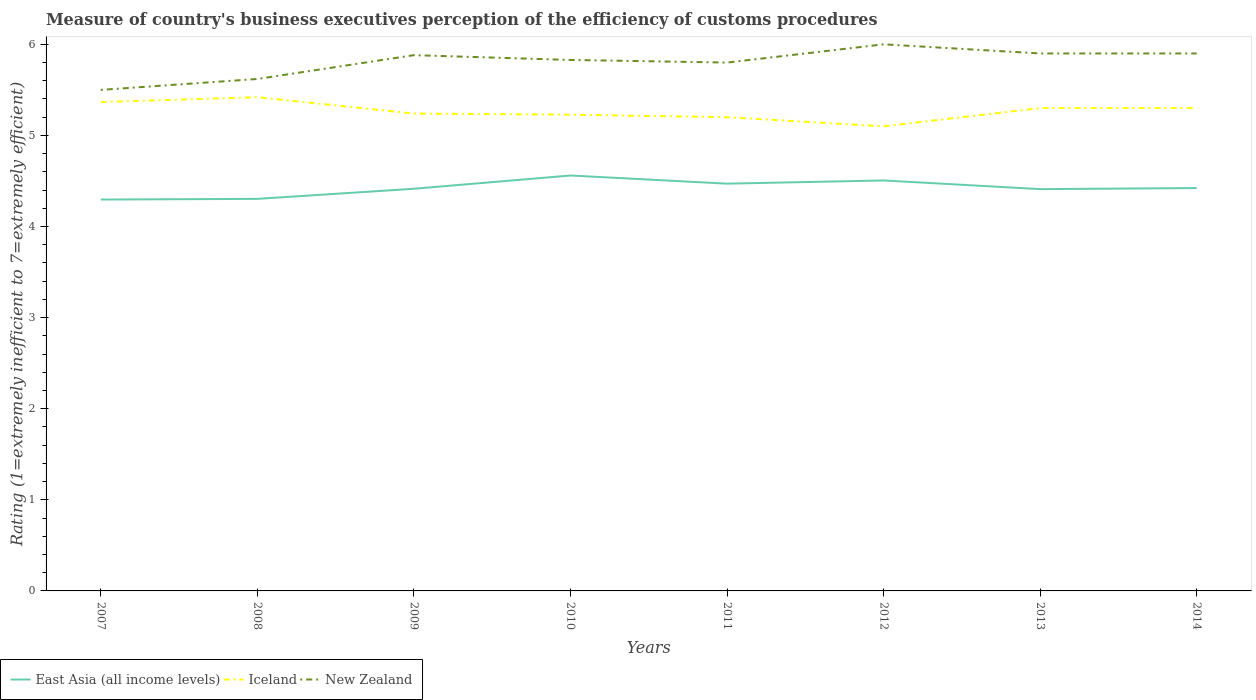How many different coloured lines are there?
Provide a succinct answer. 3. Does the line corresponding to East Asia (all income levels) intersect with the line corresponding to Iceland?
Your answer should be compact. No. Is the number of lines equal to the number of legend labels?
Your answer should be compact. Yes. Across all years, what is the maximum rating of the efficiency of customs procedure in New Zealand?
Offer a very short reply. 5.5. In which year was the rating of the efficiency of customs procedure in East Asia (all income levels) maximum?
Ensure brevity in your answer.  2007. What is the total rating of the efficiency of customs procedure in New Zealand in the graph?
Your answer should be compact. -0.07. What is the difference between the highest and the lowest rating of the efficiency of customs procedure in East Asia (all income levels)?
Give a very brief answer. 3. How many lines are there?
Give a very brief answer. 3. How many years are there in the graph?
Keep it short and to the point. 8. What is the difference between two consecutive major ticks on the Y-axis?
Offer a terse response. 1. Are the values on the major ticks of Y-axis written in scientific E-notation?
Keep it short and to the point. No. Does the graph contain any zero values?
Provide a succinct answer. No. Does the graph contain grids?
Keep it short and to the point. No. How many legend labels are there?
Your response must be concise. 3. What is the title of the graph?
Offer a terse response. Measure of country's business executives perception of the efficiency of customs procedures. What is the label or title of the X-axis?
Offer a terse response. Years. What is the label or title of the Y-axis?
Ensure brevity in your answer.  Rating (1=extremely inefficient to 7=extremely efficient). What is the Rating (1=extremely inefficient to 7=extremely efficient) of East Asia (all income levels) in 2007?
Give a very brief answer. 4.3. What is the Rating (1=extremely inefficient to 7=extremely efficient) of Iceland in 2007?
Ensure brevity in your answer.  5.37. What is the Rating (1=extremely inefficient to 7=extremely efficient) in East Asia (all income levels) in 2008?
Keep it short and to the point. 4.3. What is the Rating (1=extremely inefficient to 7=extremely efficient) in Iceland in 2008?
Your response must be concise. 5.42. What is the Rating (1=extremely inefficient to 7=extremely efficient) in New Zealand in 2008?
Give a very brief answer. 5.62. What is the Rating (1=extremely inefficient to 7=extremely efficient) of East Asia (all income levels) in 2009?
Offer a very short reply. 4.41. What is the Rating (1=extremely inefficient to 7=extremely efficient) in Iceland in 2009?
Offer a very short reply. 5.24. What is the Rating (1=extremely inefficient to 7=extremely efficient) of New Zealand in 2009?
Your response must be concise. 5.88. What is the Rating (1=extremely inefficient to 7=extremely efficient) of East Asia (all income levels) in 2010?
Provide a succinct answer. 4.56. What is the Rating (1=extremely inefficient to 7=extremely efficient) of Iceland in 2010?
Your answer should be compact. 5.23. What is the Rating (1=extremely inefficient to 7=extremely efficient) of New Zealand in 2010?
Offer a terse response. 5.83. What is the Rating (1=extremely inefficient to 7=extremely efficient) in East Asia (all income levels) in 2011?
Give a very brief answer. 4.47. What is the Rating (1=extremely inefficient to 7=extremely efficient) of East Asia (all income levels) in 2012?
Provide a short and direct response. 4.51. What is the Rating (1=extremely inefficient to 7=extremely efficient) of Iceland in 2012?
Your answer should be compact. 5.1. What is the Rating (1=extremely inefficient to 7=extremely efficient) of New Zealand in 2012?
Give a very brief answer. 6. What is the Rating (1=extremely inefficient to 7=extremely efficient) in East Asia (all income levels) in 2013?
Ensure brevity in your answer.  4.41. What is the Rating (1=extremely inefficient to 7=extremely efficient) in New Zealand in 2013?
Provide a short and direct response. 5.9. What is the Rating (1=extremely inefficient to 7=extremely efficient) in East Asia (all income levels) in 2014?
Offer a terse response. 4.42. What is the Rating (1=extremely inefficient to 7=extremely efficient) in New Zealand in 2014?
Provide a short and direct response. 5.9. Across all years, what is the maximum Rating (1=extremely inefficient to 7=extremely efficient) of East Asia (all income levels)?
Offer a very short reply. 4.56. Across all years, what is the maximum Rating (1=extremely inefficient to 7=extremely efficient) of Iceland?
Offer a terse response. 5.42. Across all years, what is the maximum Rating (1=extremely inefficient to 7=extremely efficient) of New Zealand?
Make the answer very short. 6. Across all years, what is the minimum Rating (1=extremely inefficient to 7=extremely efficient) of East Asia (all income levels)?
Keep it short and to the point. 4.3. Across all years, what is the minimum Rating (1=extremely inefficient to 7=extremely efficient) of New Zealand?
Provide a succinct answer. 5.5. What is the total Rating (1=extremely inefficient to 7=extremely efficient) in East Asia (all income levels) in the graph?
Your response must be concise. 35.38. What is the total Rating (1=extremely inefficient to 7=extremely efficient) of Iceland in the graph?
Keep it short and to the point. 42.15. What is the total Rating (1=extremely inefficient to 7=extremely efficient) in New Zealand in the graph?
Give a very brief answer. 46.43. What is the difference between the Rating (1=extremely inefficient to 7=extremely efficient) in East Asia (all income levels) in 2007 and that in 2008?
Ensure brevity in your answer.  -0.01. What is the difference between the Rating (1=extremely inefficient to 7=extremely efficient) in Iceland in 2007 and that in 2008?
Make the answer very short. -0.05. What is the difference between the Rating (1=extremely inefficient to 7=extremely efficient) of New Zealand in 2007 and that in 2008?
Keep it short and to the point. -0.12. What is the difference between the Rating (1=extremely inefficient to 7=extremely efficient) of East Asia (all income levels) in 2007 and that in 2009?
Your response must be concise. -0.12. What is the difference between the Rating (1=extremely inefficient to 7=extremely efficient) in Iceland in 2007 and that in 2009?
Provide a succinct answer. 0.13. What is the difference between the Rating (1=extremely inefficient to 7=extremely efficient) of New Zealand in 2007 and that in 2009?
Your answer should be very brief. -0.38. What is the difference between the Rating (1=extremely inefficient to 7=extremely efficient) of East Asia (all income levels) in 2007 and that in 2010?
Provide a succinct answer. -0.26. What is the difference between the Rating (1=extremely inefficient to 7=extremely efficient) in Iceland in 2007 and that in 2010?
Your answer should be very brief. 0.14. What is the difference between the Rating (1=extremely inefficient to 7=extremely efficient) in New Zealand in 2007 and that in 2010?
Make the answer very short. -0.33. What is the difference between the Rating (1=extremely inefficient to 7=extremely efficient) in East Asia (all income levels) in 2007 and that in 2011?
Give a very brief answer. -0.17. What is the difference between the Rating (1=extremely inefficient to 7=extremely efficient) in Iceland in 2007 and that in 2011?
Ensure brevity in your answer.  0.17. What is the difference between the Rating (1=extremely inefficient to 7=extremely efficient) in New Zealand in 2007 and that in 2011?
Keep it short and to the point. -0.3. What is the difference between the Rating (1=extremely inefficient to 7=extremely efficient) in East Asia (all income levels) in 2007 and that in 2012?
Provide a succinct answer. -0.21. What is the difference between the Rating (1=extremely inefficient to 7=extremely efficient) of Iceland in 2007 and that in 2012?
Your answer should be compact. 0.27. What is the difference between the Rating (1=extremely inefficient to 7=extremely efficient) in New Zealand in 2007 and that in 2012?
Keep it short and to the point. -0.5. What is the difference between the Rating (1=extremely inefficient to 7=extremely efficient) in East Asia (all income levels) in 2007 and that in 2013?
Your answer should be compact. -0.11. What is the difference between the Rating (1=extremely inefficient to 7=extremely efficient) of Iceland in 2007 and that in 2013?
Your answer should be very brief. 0.07. What is the difference between the Rating (1=extremely inefficient to 7=extremely efficient) in East Asia (all income levels) in 2007 and that in 2014?
Provide a succinct answer. -0.13. What is the difference between the Rating (1=extremely inefficient to 7=extremely efficient) in Iceland in 2007 and that in 2014?
Make the answer very short. 0.07. What is the difference between the Rating (1=extremely inefficient to 7=extremely efficient) of New Zealand in 2007 and that in 2014?
Provide a succinct answer. -0.4. What is the difference between the Rating (1=extremely inefficient to 7=extremely efficient) of East Asia (all income levels) in 2008 and that in 2009?
Give a very brief answer. -0.11. What is the difference between the Rating (1=extremely inefficient to 7=extremely efficient) in Iceland in 2008 and that in 2009?
Your response must be concise. 0.18. What is the difference between the Rating (1=extremely inefficient to 7=extremely efficient) of New Zealand in 2008 and that in 2009?
Give a very brief answer. -0.26. What is the difference between the Rating (1=extremely inefficient to 7=extremely efficient) in East Asia (all income levels) in 2008 and that in 2010?
Your answer should be compact. -0.26. What is the difference between the Rating (1=extremely inefficient to 7=extremely efficient) in Iceland in 2008 and that in 2010?
Keep it short and to the point. 0.19. What is the difference between the Rating (1=extremely inefficient to 7=extremely efficient) of New Zealand in 2008 and that in 2010?
Ensure brevity in your answer.  -0.21. What is the difference between the Rating (1=extremely inefficient to 7=extremely efficient) of East Asia (all income levels) in 2008 and that in 2011?
Provide a short and direct response. -0.17. What is the difference between the Rating (1=extremely inefficient to 7=extremely efficient) in Iceland in 2008 and that in 2011?
Your answer should be very brief. 0.22. What is the difference between the Rating (1=extremely inefficient to 7=extremely efficient) of New Zealand in 2008 and that in 2011?
Offer a terse response. -0.18. What is the difference between the Rating (1=extremely inefficient to 7=extremely efficient) of East Asia (all income levels) in 2008 and that in 2012?
Keep it short and to the point. -0.2. What is the difference between the Rating (1=extremely inefficient to 7=extremely efficient) in Iceland in 2008 and that in 2012?
Your answer should be compact. 0.32. What is the difference between the Rating (1=extremely inefficient to 7=extremely efficient) of New Zealand in 2008 and that in 2012?
Offer a very short reply. -0.38. What is the difference between the Rating (1=extremely inefficient to 7=extremely efficient) in East Asia (all income levels) in 2008 and that in 2013?
Offer a terse response. -0.11. What is the difference between the Rating (1=extremely inefficient to 7=extremely efficient) of Iceland in 2008 and that in 2013?
Make the answer very short. 0.12. What is the difference between the Rating (1=extremely inefficient to 7=extremely efficient) in New Zealand in 2008 and that in 2013?
Keep it short and to the point. -0.28. What is the difference between the Rating (1=extremely inefficient to 7=extremely efficient) in East Asia (all income levels) in 2008 and that in 2014?
Offer a terse response. -0.12. What is the difference between the Rating (1=extremely inefficient to 7=extremely efficient) in Iceland in 2008 and that in 2014?
Ensure brevity in your answer.  0.12. What is the difference between the Rating (1=extremely inefficient to 7=extremely efficient) of New Zealand in 2008 and that in 2014?
Offer a terse response. -0.28. What is the difference between the Rating (1=extremely inefficient to 7=extremely efficient) in East Asia (all income levels) in 2009 and that in 2010?
Your answer should be compact. -0.15. What is the difference between the Rating (1=extremely inefficient to 7=extremely efficient) of Iceland in 2009 and that in 2010?
Offer a very short reply. 0.01. What is the difference between the Rating (1=extremely inefficient to 7=extremely efficient) of New Zealand in 2009 and that in 2010?
Make the answer very short. 0.05. What is the difference between the Rating (1=extremely inefficient to 7=extremely efficient) in East Asia (all income levels) in 2009 and that in 2011?
Offer a very short reply. -0.06. What is the difference between the Rating (1=extremely inefficient to 7=extremely efficient) of Iceland in 2009 and that in 2011?
Offer a terse response. 0.04. What is the difference between the Rating (1=extremely inefficient to 7=extremely efficient) in New Zealand in 2009 and that in 2011?
Give a very brief answer. 0.08. What is the difference between the Rating (1=extremely inefficient to 7=extremely efficient) in East Asia (all income levels) in 2009 and that in 2012?
Make the answer very short. -0.09. What is the difference between the Rating (1=extremely inefficient to 7=extremely efficient) in Iceland in 2009 and that in 2012?
Your answer should be very brief. 0.14. What is the difference between the Rating (1=extremely inefficient to 7=extremely efficient) in New Zealand in 2009 and that in 2012?
Your response must be concise. -0.12. What is the difference between the Rating (1=extremely inefficient to 7=extremely efficient) in East Asia (all income levels) in 2009 and that in 2013?
Ensure brevity in your answer.  0. What is the difference between the Rating (1=extremely inefficient to 7=extremely efficient) of Iceland in 2009 and that in 2013?
Make the answer very short. -0.06. What is the difference between the Rating (1=extremely inefficient to 7=extremely efficient) in New Zealand in 2009 and that in 2013?
Offer a very short reply. -0.02. What is the difference between the Rating (1=extremely inefficient to 7=extremely efficient) in East Asia (all income levels) in 2009 and that in 2014?
Offer a terse response. -0.01. What is the difference between the Rating (1=extremely inefficient to 7=extremely efficient) of Iceland in 2009 and that in 2014?
Provide a short and direct response. -0.06. What is the difference between the Rating (1=extremely inefficient to 7=extremely efficient) in New Zealand in 2009 and that in 2014?
Make the answer very short. -0.02. What is the difference between the Rating (1=extremely inefficient to 7=extremely efficient) in East Asia (all income levels) in 2010 and that in 2011?
Your response must be concise. 0.09. What is the difference between the Rating (1=extremely inefficient to 7=extremely efficient) in Iceland in 2010 and that in 2011?
Keep it short and to the point. 0.03. What is the difference between the Rating (1=extremely inefficient to 7=extremely efficient) in New Zealand in 2010 and that in 2011?
Make the answer very short. 0.03. What is the difference between the Rating (1=extremely inefficient to 7=extremely efficient) of East Asia (all income levels) in 2010 and that in 2012?
Ensure brevity in your answer.  0.05. What is the difference between the Rating (1=extremely inefficient to 7=extremely efficient) in Iceland in 2010 and that in 2012?
Provide a short and direct response. 0.13. What is the difference between the Rating (1=extremely inefficient to 7=extremely efficient) in New Zealand in 2010 and that in 2012?
Provide a short and direct response. -0.17. What is the difference between the Rating (1=extremely inefficient to 7=extremely efficient) of East Asia (all income levels) in 2010 and that in 2013?
Your response must be concise. 0.15. What is the difference between the Rating (1=extremely inefficient to 7=extremely efficient) in Iceland in 2010 and that in 2013?
Your answer should be very brief. -0.07. What is the difference between the Rating (1=extremely inefficient to 7=extremely efficient) in New Zealand in 2010 and that in 2013?
Your answer should be compact. -0.07. What is the difference between the Rating (1=extremely inefficient to 7=extremely efficient) in East Asia (all income levels) in 2010 and that in 2014?
Your answer should be compact. 0.14. What is the difference between the Rating (1=extremely inefficient to 7=extremely efficient) in Iceland in 2010 and that in 2014?
Offer a very short reply. -0.07. What is the difference between the Rating (1=extremely inefficient to 7=extremely efficient) of New Zealand in 2010 and that in 2014?
Keep it short and to the point. -0.07. What is the difference between the Rating (1=extremely inefficient to 7=extremely efficient) of East Asia (all income levels) in 2011 and that in 2012?
Make the answer very short. -0.04. What is the difference between the Rating (1=extremely inefficient to 7=extremely efficient) of Iceland in 2011 and that in 2012?
Offer a very short reply. 0.1. What is the difference between the Rating (1=extremely inefficient to 7=extremely efficient) of New Zealand in 2011 and that in 2012?
Your answer should be very brief. -0.2. What is the difference between the Rating (1=extremely inefficient to 7=extremely efficient) of East Asia (all income levels) in 2011 and that in 2013?
Provide a succinct answer. 0.06. What is the difference between the Rating (1=extremely inefficient to 7=extremely efficient) in New Zealand in 2011 and that in 2013?
Your answer should be very brief. -0.1. What is the difference between the Rating (1=extremely inefficient to 7=extremely efficient) in East Asia (all income levels) in 2011 and that in 2014?
Ensure brevity in your answer.  0.05. What is the difference between the Rating (1=extremely inefficient to 7=extremely efficient) in Iceland in 2011 and that in 2014?
Provide a short and direct response. -0.1. What is the difference between the Rating (1=extremely inefficient to 7=extremely efficient) of New Zealand in 2011 and that in 2014?
Your answer should be very brief. -0.1. What is the difference between the Rating (1=extremely inefficient to 7=extremely efficient) of East Asia (all income levels) in 2012 and that in 2013?
Your response must be concise. 0.1. What is the difference between the Rating (1=extremely inefficient to 7=extremely efficient) in East Asia (all income levels) in 2012 and that in 2014?
Your response must be concise. 0.08. What is the difference between the Rating (1=extremely inefficient to 7=extremely efficient) of East Asia (all income levels) in 2013 and that in 2014?
Make the answer very short. -0.01. What is the difference between the Rating (1=extremely inefficient to 7=extremely efficient) in East Asia (all income levels) in 2007 and the Rating (1=extremely inefficient to 7=extremely efficient) in Iceland in 2008?
Ensure brevity in your answer.  -1.12. What is the difference between the Rating (1=extremely inefficient to 7=extremely efficient) of East Asia (all income levels) in 2007 and the Rating (1=extremely inefficient to 7=extremely efficient) of New Zealand in 2008?
Offer a terse response. -1.32. What is the difference between the Rating (1=extremely inefficient to 7=extremely efficient) in Iceland in 2007 and the Rating (1=extremely inefficient to 7=extremely efficient) in New Zealand in 2008?
Provide a succinct answer. -0.25. What is the difference between the Rating (1=extremely inefficient to 7=extremely efficient) of East Asia (all income levels) in 2007 and the Rating (1=extremely inefficient to 7=extremely efficient) of Iceland in 2009?
Offer a very short reply. -0.94. What is the difference between the Rating (1=extremely inefficient to 7=extremely efficient) of East Asia (all income levels) in 2007 and the Rating (1=extremely inefficient to 7=extremely efficient) of New Zealand in 2009?
Offer a very short reply. -1.58. What is the difference between the Rating (1=extremely inefficient to 7=extremely efficient) in Iceland in 2007 and the Rating (1=extremely inefficient to 7=extremely efficient) in New Zealand in 2009?
Provide a short and direct response. -0.51. What is the difference between the Rating (1=extremely inefficient to 7=extremely efficient) in East Asia (all income levels) in 2007 and the Rating (1=extremely inefficient to 7=extremely efficient) in Iceland in 2010?
Offer a very short reply. -0.93. What is the difference between the Rating (1=extremely inefficient to 7=extremely efficient) in East Asia (all income levels) in 2007 and the Rating (1=extremely inefficient to 7=extremely efficient) in New Zealand in 2010?
Your response must be concise. -1.53. What is the difference between the Rating (1=extremely inefficient to 7=extremely efficient) in Iceland in 2007 and the Rating (1=extremely inefficient to 7=extremely efficient) in New Zealand in 2010?
Your response must be concise. -0.46. What is the difference between the Rating (1=extremely inefficient to 7=extremely efficient) in East Asia (all income levels) in 2007 and the Rating (1=extremely inefficient to 7=extremely efficient) in Iceland in 2011?
Make the answer very short. -0.9. What is the difference between the Rating (1=extremely inefficient to 7=extremely efficient) in East Asia (all income levels) in 2007 and the Rating (1=extremely inefficient to 7=extremely efficient) in New Zealand in 2011?
Give a very brief answer. -1.5. What is the difference between the Rating (1=extremely inefficient to 7=extremely efficient) in Iceland in 2007 and the Rating (1=extremely inefficient to 7=extremely efficient) in New Zealand in 2011?
Provide a succinct answer. -0.43. What is the difference between the Rating (1=extremely inefficient to 7=extremely efficient) of East Asia (all income levels) in 2007 and the Rating (1=extremely inefficient to 7=extremely efficient) of Iceland in 2012?
Make the answer very short. -0.8. What is the difference between the Rating (1=extremely inefficient to 7=extremely efficient) of East Asia (all income levels) in 2007 and the Rating (1=extremely inefficient to 7=extremely efficient) of New Zealand in 2012?
Give a very brief answer. -1.7. What is the difference between the Rating (1=extremely inefficient to 7=extremely efficient) of Iceland in 2007 and the Rating (1=extremely inefficient to 7=extremely efficient) of New Zealand in 2012?
Offer a very short reply. -0.63. What is the difference between the Rating (1=extremely inefficient to 7=extremely efficient) in East Asia (all income levels) in 2007 and the Rating (1=extremely inefficient to 7=extremely efficient) in Iceland in 2013?
Your answer should be compact. -1. What is the difference between the Rating (1=extremely inefficient to 7=extremely efficient) of East Asia (all income levels) in 2007 and the Rating (1=extremely inefficient to 7=extremely efficient) of New Zealand in 2013?
Your response must be concise. -1.6. What is the difference between the Rating (1=extremely inefficient to 7=extremely efficient) of Iceland in 2007 and the Rating (1=extremely inefficient to 7=extremely efficient) of New Zealand in 2013?
Keep it short and to the point. -0.53. What is the difference between the Rating (1=extremely inefficient to 7=extremely efficient) in East Asia (all income levels) in 2007 and the Rating (1=extremely inefficient to 7=extremely efficient) in Iceland in 2014?
Ensure brevity in your answer.  -1. What is the difference between the Rating (1=extremely inefficient to 7=extremely efficient) of East Asia (all income levels) in 2007 and the Rating (1=extremely inefficient to 7=extremely efficient) of New Zealand in 2014?
Ensure brevity in your answer.  -1.6. What is the difference between the Rating (1=extremely inefficient to 7=extremely efficient) in Iceland in 2007 and the Rating (1=extremely inefficient to 7=extremely efficient) in New Zealand in 2014?
Offer a terse response. -0.53. What is the difference between the Rating (1=extremely inefficient to 7=extremely efficient) in East Asia (all income levels) in 2008 and the Rating (1=extremely inefficient to 7=extremely efficient) in Iceland in 2009?
Keep it short and to the point. -0.94. What is the difference between the Rating (1=extremely inefficient to 7=extremely efficient) of East Asia (all income levels) in 2008 and the Rating (1=extremely inefficient to 7=extremely efficient) of New Zealand in 2009?
Your answer should be compact. -1.58. What is the difference between the Rating (1=extremely inefficient to 7=extremely efficient) in Iceland in 2008 and the Rating (1=extremely inefficient to 7=extremely efficient) in New Zealand in 2009?
Keep it short and to the point. -0.46. What is the difference between the Rating (1=extremely inefficient to 7=extremely efficient) in East Asia (all income levels) in 2008 and the Rating (1=extremely inefficient to 7=extremely efficient) in Iceland in 2010?
Provide a short and direct response. -0.92. What is the difference between the Rating (1=extremely inefficient to 7=extremely efficient) in East Asia (all income levels) in 2008 and the Rating (1=extremely inefficient to 7=extremely efficient) in New Zealand in 2010?
Your answer should be compact. -1.52. What is the difference between the Rating (1=extremely inefficient to 7=extremely efficient) of Iceland in 2008 and the Rating (1=extremely inefficient to 7=extremely efficient) of New Zealand in 2010?
Offer a very short reply. -0.41. What is the difference between the Rating (1=extremely inefficient to 7=extremely efficient) of East Asia (all income levels) in 2008 and the Rating (1=extremely inefficient to 7=extremely efficient) of Iceland in 2011?
Provide a short and direct response. -0.9. What is the difference between the Rating (1=extremely inefficient to 7=extremely efficient) of East Asia (all income levels) in 2008 and the Rating (1=extremely inefficient to 7=extremely efficient) of New Zealand in 2011?
Provide a succinct answer. -1.5. What is the difference between the Rating (1=extremely inefficient to 7=extremely efficient) of Iceland in 2008 and the Rating (1=extremely inefficient to 7=extremely efficient) of New Zealand in 2011?
Your response must be concise. -0.38. What is the difference between the Rating (1=extremely inefficient to 7=extremely efficient) in East Asia (all income levels) in 2008 and the Rating (1=extremely inefficient to 7=extremely efficient) in Iceland in 2012?
Make the answer very short. -0.8. What is the difference between the Rating (1=extremely inefficient to 7=extremely efficient) of East Asia (all income levels) in 2008 and the Rating (1=extremely inefficient to 7=extremely efficient) of New Zealand in 2012?
Provide a succinct answer. -1.7. What is the difference between the Rating (1=extremely inefficient to 7=extremely efficient) in Iceland in 2008 and the Rating (1=extremely inefficient to 7=extremely efficient) in New Zealand in 2012?
Provide a succinct answer. -0.58. What is the difference between the Rating (1=extremely inefficient to 7=extremely efficient) in East Asia (all income levels) in 2008 and the Rating (1=extremely inefficient to 7=extremely efficient) in Iceland in 2013?
Your answer should be compact. -1. What is the difference between the Rating (1=extremely inefficient to 7=extremely efficient) of East Asia (all income levels) in 2008 and the Rating (1=extremely inefficient to 7=extremely efficient) of New Zealand in 2013?
Ensure brevity in your answer.  -1.6. What is the difference between the Rating (1=extremely inefficient to 7=extremely efficient) in Iceland in 2008 and the Rating (1=extremely inefficient to 7=extremely efficient) in New Zealand in 2013?
Your answer should be compact. -0.48. What is the difference between the Rating (1=extremely inefficient to 7=extremely efficient) of East Asia (all income levels) in 2008 and the Rating (1=extremely inefficient to 7=extremely efficient) of Iceland in 2014?
Provide a short and direct response. -1. What is the difference between the Rating (1=extremely inefficient to 7=extremely efficient) in East Asia (all income levels) in 2008 and the Rating (1=extremely inefficient to 7=extremely efficient) in New Zealand in 2014?
Your response must be concise. -1.6. What is the difference between the Rating (1=extremely inefficient to 7=extremely efficient) of Iceland in 2008 and the Rating (1=extremely inefficient to 7=extremely efficient) of New Zealand in 2014?
Provide a succinct answer. -0.48. What is the difference between the Rating (1=extremely inefficient to 7=extremely efficient) in East Asia (all income levels) in 2009 and the Rating (1=extremely inefficient to 7=extremely efficient) in Iceland in 2010?
Make the answer very short. -0.81. What is the difference between the Rating (1=extremely inefficient to 7=extremely efficient) of East Asia (all income levels) in 2009 and the Rating (1=extremely inefficient to 7=extremely efficient) of New Zealand in 2010?
Offer a very short reply. -1.41. What is the difference between the Rating (1=extremely inefficient to 7=extremely efficient) of Iceland in 2009 and the Rating (1=extremely inefficient to 7=extremely efficient) of New Zealand in 2010?
Provide a short and direct response. -0.59. What is the difference between the Rating (1=extremely inefficient to 7=extremely efficient) of East Asia (all income levels) in 2009 and the Rating (1=extremely inefficient to 7=extremely efficient) of Iceland in 2011?
Make the answer very short. -0.79. What is the difference between the Rating (1=extremely inefficient to 7=extremely efficient) in East Asia (all income levels) in 2009 and the Rating (1=extremely inefficient to 7=extremely efficient) in New Zealand in 2011?
Offer a terse response. -1.39. What is the difference between the Rating (1=extremely inefficient to 7=extremely efficient) of Iceland in 2009 and the Rating (1=extremely inefficient to 7=extremely efficient) of New Zealand in 2011?
Keep it short and to the point. -0.56. What is the difference between the Rating (1=extremely inefficient to 7=extremely efficient) in East Asia (all income levels) in 2009 and the Rating (1=extremely inefficient to 7=extremely efficient) in Iceland in 2012?
Your response must be concise. -0.69. What is the difference between the Rating (1=extremely inefficient to 7=extremely efficient) of East Asia (all income levels) in 2009 and the Rating (1=extremely inefficient to 7=extremely efficient) of New Zealand in 2012?
Your response must be concise. -1.59. What is the difference between the Rating (1=extremely inefficient to 7=extremely efficient) in Iceland in 2009 and the Rating (1=extremely inefficient to 7=extremely efficient) in New Zealand in 2012?
Make the answer very short. -0.76. What is the difference between the Rating (1=extremely inefficient to 7=extremely efficient) in East Asia (all income levels) in 2009 and the Rating (1=extremely inefficient to 7=extremely efficient) in Iceland in 2013?
Ensure brevity in your answer.  -0.89. What is the difference between the Rating (1=extremely inefficient to 7=extremely efficient) in East Asia (all income levels) in 2009 and the Rating (1=extremely inefficient to 7=extremely efficient) in New Zealand in 2013?
Make the answer very short. -1.49. What is the difference between the Rating (1=extremely inefficient to 7=extremely efficient) in Iceland in 2009 and the Rating (1=extremely inefficient to 7=extremely efficient) in New Zealand in 2013?
Provide a short and direct response. -0.66. What is the difference between the Rating (1=extremely inefficient to 7=extremely efficient) in East Asia (all income levels) in 2009 and the Rating (1=extremely inefficient to 7=extremely efficient) in Iceland in 2014?
Provide a short and direct response. -0.89. What is the difference between the Rating (1=extremely inefficient to 7=extremely efficient) in East Asia (all income levels) in 2009 and the Rating (1=extremely inefficient to 7=extremely efficient) in New Zealand in 2014?
Offer a very short reply. -1.49. What is the difference between the Rating (1=extremely inefficient to 7=extremely efficient) of Iceland in 2009 and the Rating (1=extremely inefficient to 7=extremely efficient) of New Zealand in 2014?
Provide a short and direct response. -0.66. What is the difference between the Rating (1=extremely inefficient to 7=extremely efficient) in East Asia (all income levels) in 2010 and the Rating (1=extremely inefficient to 7=extremely efficient) in Iceland in 2011?
Your response must be concise. -0.64. What is the difference between the Rating (1=extremely inefficient to 7=extremely efficient) in East Asia (all income levels) in 2010 and the Rating (1=extremely inefficient to 7=extremely efficient) in New Zealand in 2011?
Provide a short and direct response. -1.24. What is the difference between the Rating (1=extremely inefficient to 7=extremely efficient) in Iceland in 2010 and the Rating (1=extremely inefficient to 7=extremely efficient) in New Zealand in 2011?
Your answer should be very brief. -0.57. What is the difference between the Rating (1=extremely inefficient to 7=extremely efficient) in East Asia (all income levels) in 2010 and the Rating (1=extremely inefficient to 7=extremely efficient) in Iceland in 2012?
Provide a succinct answer. -0.54. What is the difference between the Rating (1=extremely inefficient to 7=extremely efficient) of East Asia (all income levels) in 2010 and the Rating (1=extremely inefficient to 7=extremely efficient) of New Zealand in 2012?
Provide a short and direct response. -1.44. What is the difference between the Rating (1=extremely inefficient to 7=extremely efficient) in Iceland in 2010 and the Rating (1=extremely inefficient to 7=extremely efficient) in New Zealand in 2012?
Your answer should be very brief. -0.77. What is the difference between the Rating (1=extremely inefficient to 7=extremely efficient) of East Asia (all income levels) in 2010 and the Rating (1=extremely inefficient to 7=extremely efficient) of Iceland in 2013?
Offer a terse response. -0.74. What is the difference between the Rating (1=extremely inefficient to 7=extremely efficient) of East Asia (all income levels) in 2010 and the Rating (1=extremely inefficient to 7=extremely efficient) of New Zealand in 2013?
Your answer should be very brief. -1.34. What is the difference between the Rating (1=extremely inefficient to 7=extremely efficient) of Iceland in 2010 and the Rating (1=extremely inefficient to 7=extremely efficient) of New Zealand in 2013?
Your answer should be compact. -0.67. What is the difference between the Rating (1=extremely inefficient to 7=extremely efficient) of East Asia (all income levels) in 2010 and the Rating (1=extremely inefficient to 7=extremely efficient) of Iceland in 2014?
Ensure brevity in your answer.  -0.74. What is the difference between the Rating (1=extremely inefficient to 7=extremely efficient) of East Asia (all income levels) in 2010 and the Rating (1=extremely inefficient to 7=extremely efficient) of New Zealand in 2014?
Keep it short and to the point. -1.34. What is the difference between the Rating (1=extremely inefficient to 7=extremely efficient) of Iceland in 2010 and the Rating (1=extremely inefficient to 7=extremely efficient) of New Zealand in 2014?
Make the answer very short. -0.67. What is the difference between the Rating (1=extremely inefficient to 7=extremely efficient) of East Asia (all income levels) in 2011 and the Rating (1=extremely inefficient to 7=extremely efficient) of Iceland in 2012?
Offer a terse response. -0.63. What is the difference between the Rating (1=extremely inefficient to 7=extremely efficient) in East Asia (all income levels) in 2011 and the Rating (1=extremely inefficient to 7=extremely efficient) in New Zealand in 2012?
Your response must be concise. -1.53. What is the difference between the Rating (1=extremely inefficient to 7=extremely efficient) of Iceland in 2011 and the Rating (1=extremely inefficient to 7=extremely efficient) of New Zealand in 2012?
Keep it short and to the point. -0.8. What is the difference between the Rating (1=extremely inefficient to 7=extremely efficient) in East Asia (all income levels) in 2011 and the Rating (1=extremely inefficient to 7=extremely efficient) in Iceland in 2013?
Make the answer very short. -0.83. What is the difference between the Rating (1=extremely inefficient to 7=extremely efficient) of East Asia (all income levels) in 2011 and the Rating (1=extremely inefficient to 7=extremely efficient) of New Zealand in 2013?
Offer a terse response. -1.43. What is the difference between the Rating (1=extremely inefficient to 7=extremely efficient) of Iceland in 2011 and the Rating (1=extremely inefficient to 7=extremely efficient) of New Zealand in 2013?
Offer a very short reply. -0.7. What is the difference between the Rating (1=extremely inefficient to 7=extremely efficient) of East Asia (all income levels) in 2011 and the Rating (1=extremely inefficient to 7=extremely efficient) of Iceland in 2014?
Keep it short and to the point. -0.83. What is the difference between the Rating (1=extremely inefficient to 7=extremely efficient) of East Asia (all income levels) in 2011 and the Rating (1=extremely inefficient to 7=extremely efficient) of New Zealand in 2014?
Offer a very short reply. -1.43. What is the difference between the Rating (1=extremely inefficient to 7=extremely efficient) of East Asia (all income levels) in 2012 and the Rating (1=extremely inefficient to 7=extremely efficient) of Iceland in 2013?
Offer a very short reply. -0.79. What is the difference between the Rating (1=extremely inefficient to 7=extremely efficient) in East Asia (all income levels) in 2012 and the Rating (1=extremely inefficient to 7=extremely efficient) in New Zealand in 2013?
Offer a very short reply. -1.39. What is the difference between the Rating (1=extremely inefficient to 7=extremely efficient) of Iceland in 2012 and the Rating (1=extremely inefficient to 7=extremely efficient) of New Zealand in 2013?
Provide a short and direct response. -0.8. What is the difference between the Rating (1=extremely inefficient to 7=extremely efficient) of East Asia (all income levels) in 2012 and the Rating (1=extremely inefficient to 7=extremely efficient) of Iceland in 2014?
Provide a short and direct response. -0.79. What is the difference between the Rating (1=extremely inefficient to 7=extremely efficient) in East Asia (all income levels) in 2012 and the Rating (1=extremely inefficient to 7=extremely efficient) in New Zealand in 2014?
Provide a succinct answer. -1.39. What is the difference between the Rating (1=extremely inefficient to 7=extremely efficient) of East Asia (all income levels) in 2013 and the Rating (1=extremely inefficient to 7=extremely efficient) of Iceland in 2014?
Keep it short and to the point. -0.89. What is the difference between the Rating (1=extremely inefficient to 7=extremely efficient) in East Asia (all income levels) in 2013 and the Rating (1=extremely inefficient to 7=extremely efficient) in New Zealand in 2014?
Make the answer very short. -1.49. What is the difference between the Rating (1=extremely inefficient to 7=extremely efficient) in Iceland in 2013 and the Rating (1=extremely inefficient to 7=extremely efficient) in New Zealand in 2014?
Your answer should be compact. -0.6. What is the average Rating (1=extremely inefficient to 7=extremely efficient) of East Asia (all income levels) per year?
Offer a terse response. 4.42. What is the average Rating (1=extremely inefficient to 7=extremely efficient) of Iceland per year?
Offer a very short reply. 5.27. What is the average Rating (1=extremely inefficient to 7=extremely efficient) of New Zealand per year?
Make the answer very short. 5.8. In the year 2007, what is the difference between the Rating (1=extremely inefficient to 7=extremely efficient) of East Asia (all income levels) and Rating (1=extremely inefficient to 7=extremely efficient) of Iceland?
Your answer should be compact. -1.07. In the year 2007, what is the difference between the Rating (1=extremely inefficient to 7=extremely efficient) of East Asia (all income levels) and Rating (1=extremely inefficient to 7=extremely efficient) of New Zealand?
Provide a short and direct response. -1.2. In the year 2007, what is the difference between the Rating (1=extremely inefficient to 7=extremely efficient) in Iceland and Rating (1=extremely inefficient to 7=extremely efficient) in New Zealand?
Provide a succinct answer. -0.13. In the year 2008, what is the difference between the Rating (1=extremely inefficient to 7=extremely efficient) of East Asia (all income levels) and Rating (1=extremely inefficient to 7=extremely efficient) of Iceland?
Ensure brevity in your answer.  -1.12. In the year 2008, what is the difference between the Rating (1=extremely inefficient to 7=extremely efficient) of East Asia (all income levels) and Rating (1=extremely inefficient to 7=extremely efficient) of New Zealand?
Make the answer very short. -1.32. In the year 2008, what is the difference between the Rating (1=extremely inefficient to 7=extremely efficient) of Iceland and Rating (1=extremely inefficient to 7=extremely efficient) of New Zealand?
Your answer should be very brief. -0.2. In the year 2009, what is the difference between the Rating (1=extremely inefficient to 7=extremely efficient) of East Asia (all income levels) and Rating (1=extremely inefficient to 7=extremely efficient) of Iceland?
Your answer should be very brief. -0.83. In the year 2009, what is the difference between the Rating (1=extremely inefficient to 7=extremely efficient) of East Asia (all income levels) and Rating (1=extremely inefficient to 7=extremely efficient) of New Zealand?
Ensure brevity in your answer.  -1.47. In the year 2009, what is the difference between the Rating (1=extremely inefficient to 7=extremely efficient) in Iceland and Rating (1=extremely inefficient to 7=extremely efficient) in New Zealand?
Provide a short and direct response. -0.64. In the year 2010, what is the difference between the Rating (1=extremely inefficient to 7=extremely efficient) of East Asia (all income levels) and Rating (1=extremely inefficient to 7=extremely efficient) of Iceland?
Make the answer very short. -0.67. In the year 2010, what is the difference between the Rating (1=extremely inefficient to 7=extremely efficient) of East Asia (all income levels) and Rating (1=extremely inefficient to 7=extremely efficient) of New Zealand?
Provide a succinct answer. -1.27. In the year 2010, what is the difference between the Rating (1=extremely inefficient to 7=extremely efficient) of Iceland and Rating (1=extremely inefficient to 7=extremely efficient) of New Zealand?
Your answer should be compact. -0.6. In the year 2011, what is the difference between the Rating (1=extremely inefficient to 7=extremely efficient) in East Asia (all income levels) and Rating (1=extremely inefficient to 7=extremely efficient) in Iceland?
Keep it short and to the point. -0.73. In the year 2011, what is the difference between the Rating (1=extremely inefficient to 7=extremely efficient) in East Asia (all income levels) and Rating (1=extremely inefficient to 7=extremely efficient) in New Zealand?
Offer a very short reply. -1.33. In the year 2012, what is the difference between the Rating (1=extremely inefficient to 7=extremely efficient) of East Asia (all income levels) and Rating (1=extremely inefficient to 7=extremely efficient) of Iceland?
Offer a very short reply. -0.59. In the year 2012, what is the difference between the Rating (1=extremely inefficient to 7=extremely efficient) in East Asia (all income levels) and Rating (1=extremely inefficient to 7=extremely efficient) in New Zealand?
Your answer should be very brief. -1.49. In the year 2013, what is the difference between the Rating (1=extremely inefficient to 7=extremely efficient) in East Asia (all income levels) and Rating (1=extremely inefficient to 7=extremely efficient) in Iceland?
Your answer should be compact. -0.89. In the year 2013, what is the difference between the Rating (1=extremely inefficient to 7=extremely efficient) of East Asia (all income levels) and Rating (1=extremely inefficient to 7=extremely efficient) of New Zealand?
Provide a succinct answer. -1.49. In the year 2014, what is the difference between the Rating (1=extremely inefficient to 7=extremely efficient) of East Asia (all income levels) and Rating (1=extremely inefficient to 7=extremely efficient) of Iceland?
Provide a succinct answer. -0.88. In the year 2014, what is the difference between the Rating (1=extremely inefficient to 7=extremely efficient) in East Asia (all income levels) and Rating (1=extremely inefficient to 7=extremely efficient) in New Zealand?
Your answer should be very brief. -1.48. What is the ratio of the Rating (1=extremely inefficient to 7=extremely efficient) of East Asia (all income levels) in 2007 to that in 2008?
Provide a succinct answer. 1. What is the ratio of the Rating (1=extremely inefficient to 7=extremely efficient) of Iceland in 2007 to that in 2008?
Ensure brevity in your answer.  0.99. What is the ratio of the Rating (1=extremely inefficient to 7=extremely efficient) in New Zealand in 2007 to that in 2008?
Provide a succinct answer. 0.98. What is the ratio of the Rating (1=extremely inefficient to 7=extremely efficient) of East Asia (all income levels) in 2007 to that in 2009?
Your response must be concise. 0.97. What is the ratio of the Rating (1=extremely inefficient to 7=extremely efficient) of Iceland in 2007 to that in 2009?
Offer a very short reply. 1.02. What is the ratio of the Rating (1=extremely inefficient to 7=extremely efficient) of New Zealand in 2007 to that in 2009?
Give a very brief answer. 0.94. What is the ratio of the Rating (1=extremely inefficient to 7=extremely efficient) of East Asia (all income levels) in 2007 to that in 2010?
Make the answer very short. 0.94. What is the ratio of the Rating (1=extremely inefficient to 7=extremely efficient) of Iceland in 2007 to that in 2010?
Your answer should be compact. 1.03. What is the ratio of the Rating (1=extremely inefficient to 7=extremely efficient) of New Zealand in 2007 to that in 2010?
Offer a very short reply. 0.94. What is the ratio of the Rating (1=extremely inefficient to 7=extremely efficient) of East Asia (all income levels) in 2007 to that in 2011?
Your answer should be compact. 0.96. What is the ratio of the Rating (1=extremely inefficient to 7=extremely efficient) in Iceland in 2007 to that in 2011?
Keep it short and to the point. 1.03. What is the ratio of the Rating (1=extremely inefficient to 7=extremely efficient) of New Zealand in 2007 to that in 2011?
Provide a succinct answer. 0.95. What is the ratio of the Rating (1=extremely inefficient to 7=extremely efficient) of East Asia (all income levels) in 2007 to that in 2012?
Keep it short and to the point. 0.95. What is the ratio of the Rating (1=extremely inefficient to 7=extremely efficient) of Iceland in 2007 to that in 2012?
Make the answer very short. 1.05. What is the ratio of the Rating (1=extremely inefficient to 7=extremely efficient) in New Zealand in 2007 to that in 2012?
Your response must be concise. 0.92. What is the ratio of the Rating (1=extremely inefficient to 7=extremely efficient) in East Asia (all income levels) in 2007 to that in 2013?
Your answer should be compact. 0.97. What is the ratio of the Rating (1=extremely inefficient to 7=extremely efficient) of Iceland in 2007 to that in 2013?
Provide a short and direct response. 1.01. What is the ratio of the Rating (1=extremely inefficient to 7=extremely efficient) in New Zealand in 2007 to that in 2013?
Offer a terse response. 0.93. What is the ratio of the Rating (1=extremely inefficient to 7=extremely efficient) of East Asia (all income levels) in 2007 to that in 2014?
Keep it short and to the point. 0.97. What is the ratio of the Rating (1=extremely inefficient to 7=extremely efficient) in Iceland in 2007 to that in 2014?
Ensure brevity in your answer.  1.01. What is the ratio of the Rating (1=extremely inefficient to 7=extremely efficient) of New Zealand in 2007 to that in 2014?
Give a very brief answer. 0.93. What is the ratio of the Rating (1=extremely inefficient to 7=extremely efficient) in East Asia (all income levels) in 2008 to that in 2009?
Make the answer very short. 0.97. What is the ratio of the Rating (1=extremely inefficient to 7=extremely efficient) of Iceland in 2008 to that in 2009?
Ensure brevity in your answer.  1.03. What is the ratio of the Rating (1=extremely inefficient to 7=extremely efficient) in New Zealand in 2008 to that in 2009?
Ensure brevity in your answer.  0.96. What is the ratio of the Rating (1=extremely inefficient to 7=extremely efficient) in East Asia (all income levels) in 2008 to that in 2010?
Your answer should be very brief. 0.94. What is the ratio of the Rating (1=extremely inefficient to 7=extremely efficient) of Iceland in 2008 to that in 2010?
Make the answer very short. 1.04. What is the ratio of the Rating (1=extremely inefficient to 7=extremely efficient) of New Zealand in 2008 to that in 2010?
Offer a terse response. 0.96. What is the ratio of the Rating (1=extremely inefficient to 7=extremely efficient) in East Asia (all income levels) in 2008 to that in 2011?
Your answer should be compact. 0.96. What is the ratio of the Rating (1=extremely inefficient to 7=extremely efficient) of Iceland in 2008 to that in 2011?
Keep it short and to the point. 1.04. What is the ratio of the Rating (1=extremely inefficient to 7=extremely efficient) in New Zealand in 2008 to that in 2011?
Make the answer very short. 0.97. What is the ratio of the Rating (1=extremely inefficient to 7=extremely efficient) of East Asia (all income levels) in 2008 to that in 2012?
Make the answer very short. 0.96. What is the ratio of the Rating (1=extremely inefficient to 7=extremely efficient) in Iceland in 2008 to that in 2012?
Offer a terse response. 1.06. What is the ratio of the Rating (1=extremely inefficient to 7=extremely efficient) of New Zealand in 2008 to that in 2012?
Provide a succinct answer. 0.94. What is the ratio of the Rating (1=extremely inefficient to 7=extremely efficient) of East Asia (all income levels) in 2008 to that in 2013?
Offer a terse response. 0.98. What is the ratio of the Rating (1=extremely inefficient to 7=extremely efficient) of Iceland in 2008 to that in 2013?
Your answer should be very brief. 1.02. What is the ratio of the Rating (1=extremely inefficient to 7=extremely efficient) in New Zealand in 2008 to that in 2013?
Your answer should be compact. 0.95. What is the ratio of the Rating (1=extremely inefficient to 7=extremely efficient) in East Asia (all income levels) in 2008 to that in 2014?
Provide a succinct answer. 0.97. What is the ratio of the Rating (1=extremely inefficient to 7=extremely efficient) of Iceland in 2008 to that in 2014?
Offer a terse response. 1.02. What is the ratio of the Rating (1=extremely inefficient to 7=extremely efficient) in New Zealand in 2008 to that in 2014?
Make the answer very short. 0.95. What is the ratio of the Rating (1=extremely inefficient to 7=extremely efficient) in East Asia (all income levels) in 2009 to that in 2010?
Provide a succinct answer. 0.97. What is the ratio of the Rating (1=extremely inefficient to 7=extremely efficient) of East Asia (all income levels) in 2009 to that in 2011?
Your answer should be very brief. 0.99. What is the ratio of the Rating (1=extremely inefficient to 7=extremely efficient) in Iceland in 2009 to that in 2011?
Give a very brief answer. 1.01. What is the ratio of the Rating (1=extremely inefficient to 7=extremely efficient) of New Zealand in 2009 to that in 2011?
Offer a terse response. 1.01. What is the ratio of the Rating (1=extremely inefficient to 7=extremely efficient) in East Asia (all income levels) in 2009 to that in 2012?
Keep it short and to the point. 0.98. What is the ratio of the Rating (1=extremely inefficient to 7=extremely efficient) of Iceland in 2009 to that in 2012?
Ensure brevity in your answer.  1.03. What is the ratio of the Rating (1=extremely inefficient to 7=extremely efficient) of New Zealand in 2009 to that in 2012?
Offer a very short reply. 0.98. What is the ratio of the Rating (1=extremely inefficient to 7=extremely efficient) in East Asia (all income levels) in 2009 to that in 2013?
Your response must be concise. 1. What is the ratio of the Rating (1=extremely inefficient to 7=extremely efficient) of Iceland in 2009 to that in 2013?
Provide a succinct answer. 0.99. What is the ratio of the Rating (1=extremely inefficient to 7=extremely efficient) in New Zealand in 2009 to that in 2013?
Your answer should be compact. 1. What is the ratio of the Rating (1=extremely inefficient to 7=extremely efficient) in Iceland in 2009 to that in 2014?
Your answer should be very brief. 0.99. What is the ratio of the Rating (1=extremely inefficient to 7=extremely efficient) of New Zealand in 2009 to that in 2014?
Ensure brevity in your answer.  1. What is the ratio of the Rating (1=extremely inefficient to 7=extremely efficient) in East Asia (all income levels) in 2010 to that in 2011?
Provide a succinct answer. 1.02. What is the ratio of the Rating (1=extremely inefficient to 7=extremely efficient) of Iceland in 2010 to that in 2011?
Ensure brevity in your answer.  1.01. What is the ratio of the Rating (1=extremely inefficient to 7=extremely efficient) in Iceland in 2010 to that in 2012?
Your response must be concise. 1.03. What is the ratio of the Rating (1=extremely inefficient to 7=extremely efficient) of New Zealand in 2010 to that in 2012?
Provide a succinct answer. 0.97. What is the ratio of the Rating (1=extremely inefficient to 7=extremely efficient) of East Asia (all income levels) in 2010 to that in 2013?
Make the answer very short. 1.03. What is the ratio of the Rating (1=extremely inefficient to 7=extremely efficient) of Iceland in 2010 to that in 2013?
Your answer should be compact. 0.99. What is the ratio of the Rating (1=extremely inefficient to 7=extremely efficient) in New Zealand in 2010 to that in 2013?
Your answer should be compact. 0.99. What is the ratio of the Rating (1=extremely inefficient to 7=extremely efficient) of East Asia (all income levels) in 2010 to that in 2014?
Your answer should be very brief. 1.03. What is the ratio of the Rating (1=extremely inefficient to 7=extremely efficient) of Iceland in 2010 to that in 2014?
Your answer should be compact. 0.99. What is the ratio of the Rating (1=extremely inefficient to 7=extremely efficient) of New Zealand in 2010 to that in 2014?
Provide a succinct answer. 0.99. What is the ratio of the Rating (1=extremely inefficient to 7=extremely efficient) in Iceland in 2011 to that in 2012?
Offer a very short reply. 1.02. What is the ratio of the Rating (1=extremely inefficient to 7=extremely efficient) of New Zealand in 2011 to that in 2012?
Ensure brevity in your answer.  0.97. What is the ratio of the Rating (1=extremely inefficient to 7=extremely efficient) in East Asia (all income levels) in 2011 to that in 2013?
Offer a terse response. 1.01. What is the ratio of the Rating (1=extremely inefficient to 7=extremely efficient) of Iceland in 2011 to that in 2013?
Provide a succinct answer. 0.98. What is the ratio of the Rating (1=extremely inefficient to 7=extremely efficient) of New Zealand in 2011 to that in 2013?
Offer a very short reply. 0.98. What is the ratio of the Rating (1=extremely inefficient to 7=extremely efficient) of East Asia (all income levels) in 2011 to that in 2014?
Keep it short and to the point. 1.01. What is the ratio of the Rating (1=extremely inefficient to 7=extremely efficient) of Iceland in 2011 to that in 2014?
Provide a short and direct response. 0.98. What is the ratio of the Rating (1=extremely inefficient to 7=extremely efficient) in New Zealand in 2011 to that in 2014?
Provide a short and direct response. 0.98. What is the ratio of the Rating (1=extremely inefficient to 7=extremely efficient) in East Asia (all income levels) in 2012 to that in 2013?
Offer a terse response. 1.02. What is the ratio of the Rating (1=extremely inefficient to 7=extremely efficient) in Iceland in 2012 to that in 2013?
Provide a succinct answer. 0.96. What is the ratio of the Rating (1=extremely inefficient to 7=extremely efficient) in New Zealand in 2012 to that in 2013?
Give a very brief answer. 1.02. What is the ratio of the Rating (1=extremely inefficient to 7=extremely efficient) in East Asia (all income levels) in 2012 to that in 2014?
Ensure brevity in your answer.  1.02. What is the ratio of the Rating (1=extremely inefficient to 7=extremely efficient) in Iceland in 2012 to that in 2014?
Ensure brevity in your answer.  0.96. What is the ratio of the Rating (1=extremely inefficient to 7=extremely efficient) of New Zealand in 2012 to that in 2014?
Keep it short and to the point. 1.02. What is the ratio of the Rating (1=extremely inefficient to 7=extremely efficient) of East Asia (all income levels) in 2013 to that in 2014?
Keep it short and to the point. 1. What is the difference between the highest and the second highest Rating (1=extremely inefficient to 7=extremely efficient) in East Asia (all income levels)?
Keep it short and to the point. 0.05. What is the difference between the highest and the second highest Rating (1=extremely inefficient to 7=extremely efficient) in Iceland?
Ensure brevity in your answer.  0.05. What is the difference between the highest and the second highest Rating (1=extremely inefficient to 7=extremely efficient) of New Zealand?
Provide a succinct answer. 0.1. What is the difference between the highest and the lowest Rating (1=extremely inefficient to 7=extremely efficient) in East Asia (all income levels)?
Make the answer very short. 0.26. What is the difference between the highest and the lowest Rating (1=extremely inefficient to 7=extremely efficient) in Iceland?
Your answer should be compact. 0.32. What is the difference between the highest and the lowest Rating (1=extremely inefficient to 7=extremely efficient) of New Zealand?
Your answer should be very brief. 0.5. 